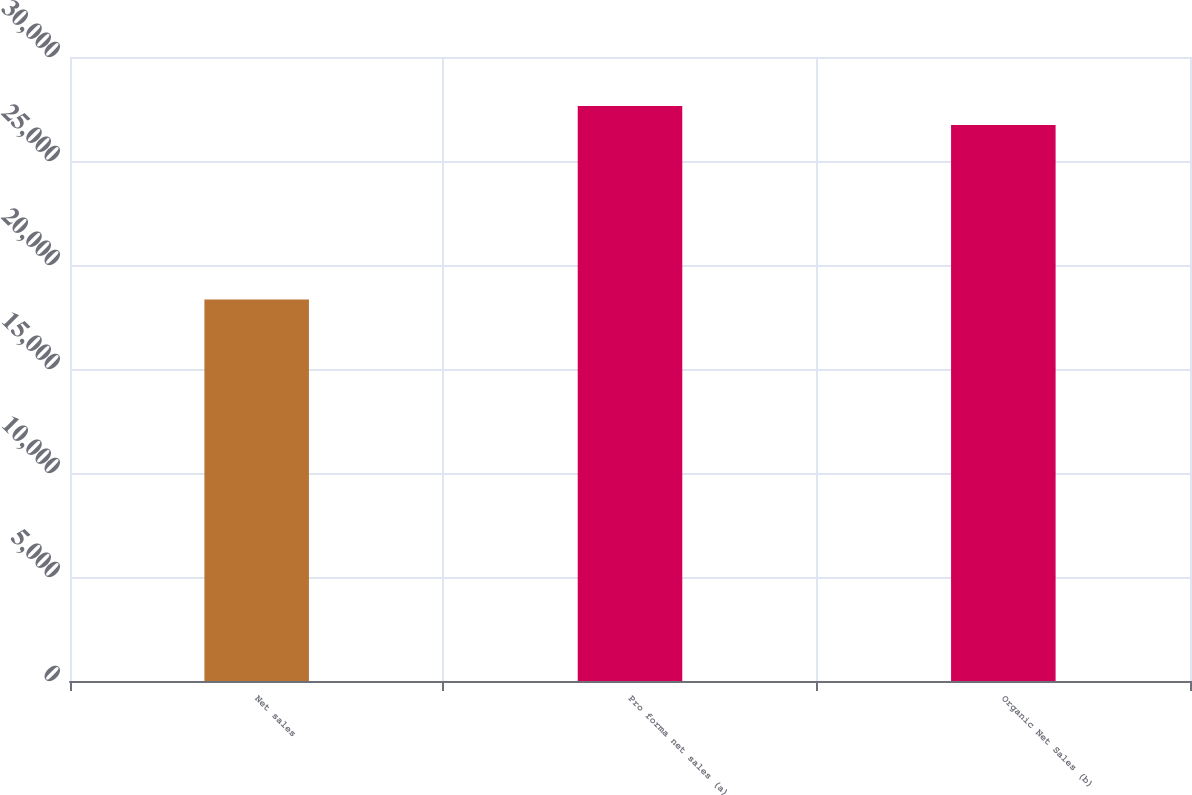<chart> <loc_0><loc_0><loc_500><loc_500><bar_chart><fcel>Net sales<fcel>Pro forma net sales (a)<fcel>Organic Net Sales (b)<nl><fcel>18338<fcel>27638.9<fcel>26728<nl></chart> 